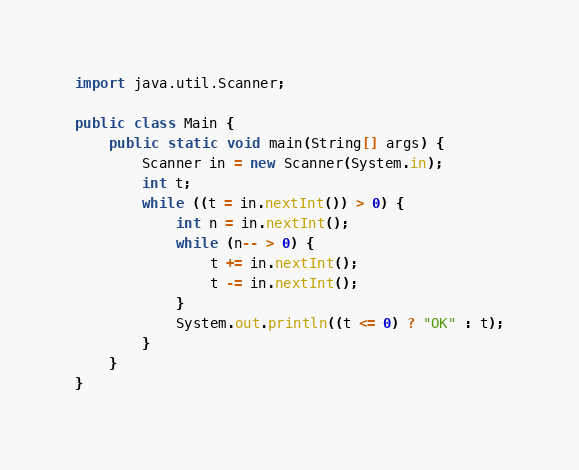<code> <loc_0><loc_0><loc_500><loc_500><_Java_>import java.util.Scanner;

public class Main {
	public static void main(String[] args) {
		Scanner in = new Scanner(System.in);
		int t;
		while ((t = in.nextInt()) > 0) {
			int n = in.nextInt();
			while (n-- > 0) {
				t += in.nextInt();
				t -= in.nextInt();
			}
			System.out.println((t <= 0) ? "OK" : t);
		}
	}
}</code> 